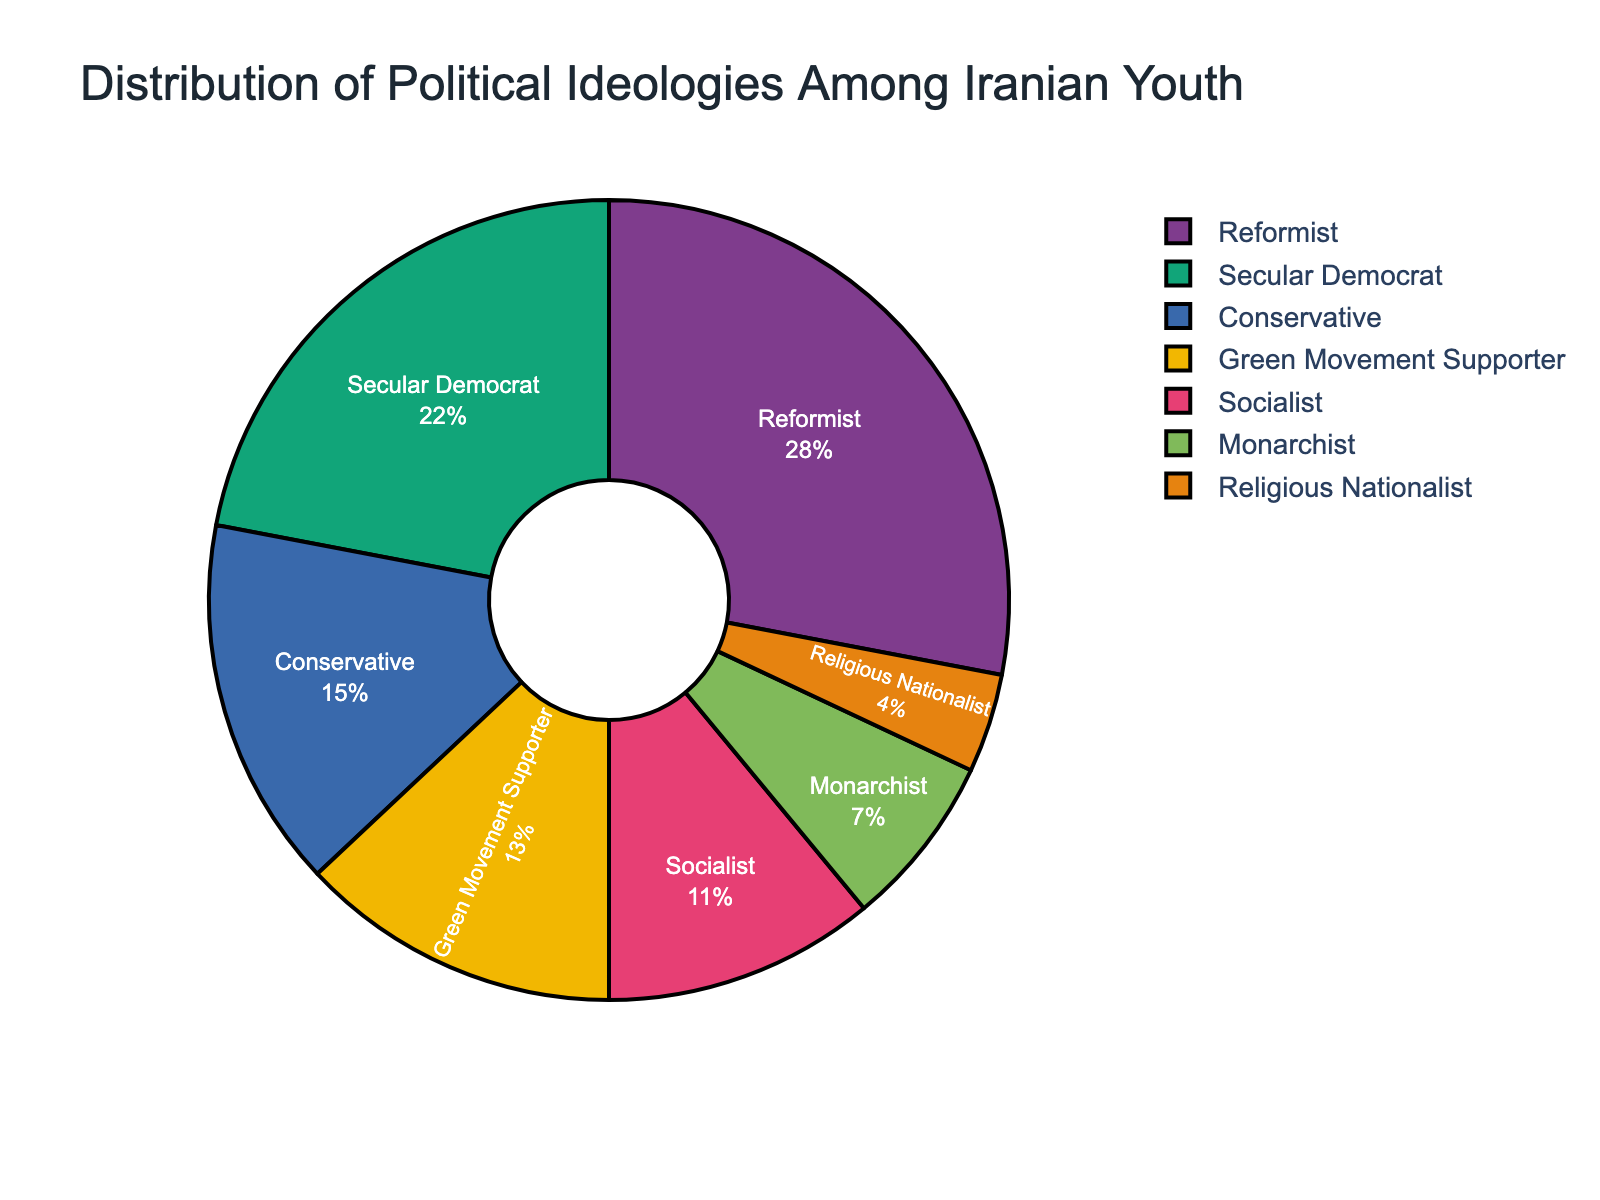What's the largest ideological group among Iranian youth? To determine the largest group, examine the percentages for each ideology. The group with the highest percentage is the largest. Reformist has the highest percentage at 28%.
Answer: Reformist Which two ideologies have the smallest percentages, and what's their combined percentage? Identify the groups with the smallest percentages by looking at the data: Religious Nationalist (4%) and Monarchist (7%). Add these percentages together to find the combined percentage: 4% + 7% = 11%.
Answer: Religious Nationalist and Monarchist, 11% How much greater is the percentage of Secular Democrats compared to Conservatives? Find the percentages for Secular Democrats (22%) and Conservatives (15%). Subtract the smaller percentage from the larger one: 22% - 15% = 7%.
Answer: 7% What is the total percentage of youth supporting ideologies considered reformist or opposition groups (Reformist, Secular Democrat, Green Movement Supporter)? Sum the percentages for Reformist (28%), Secular Democrat (22%), and Green Movement Supporter (13%): 28% + 22% + 13% = 63%.
Answer: 63% How does the percentage of Socialist supporters compare with that of Green Movement Supporters? Compare the percentages for Socialists (11%) and Green Movement Supporters (13%). The Green Movement Supporters have a higher percentage.
Answer: Green Movement Supporters have a higher percentage What is the difference between the percentage of Monarchists and Religious Nationalists? Find the percentages for Monarchists (7%) and Religious Nationalists (4%). Subtract the smaller percentage from the larger one: 7% - 4% = 3%.
Answer: 3% Is the percentage of Conservative youth higher or lower than the combined percentage of Monarchists and Religious Nationalists? Calculate the combined percentage for Monarchists (7%) and Religious Nationalists (4%): 7% + 4% = 11%. Compare this to the percentage for Conservatives (15%). 15% is higher than 11%.
Answer: Higher Which ideological group represents the smallest fraction of Iranian youth? Locate the group with the smallest percentage on the pie chart, which is Religious Nationalist with 4%.
Answer: Religious Nationalist 